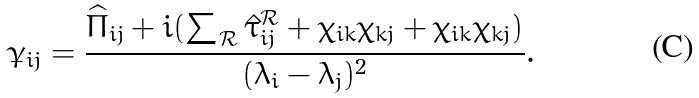<formula> <loc_0><loc_0><loc_500><loc_500>\dot { \gamma } _ { i j } = \frac { \widehat { \Pi } _ { i j } + i ( \sum _ { \mathcal { R } } \hat { \tau } ^ { \mathcal { R } } _ { i j } + \chi _ { i k } \bar { \chi } _ { k j } + \bar { \chi } _ { i k } \chi _ { k j } ) } { ( \lambda _ { i } - \lambda _ { j } ) ^ { 2 } } .</formula> 